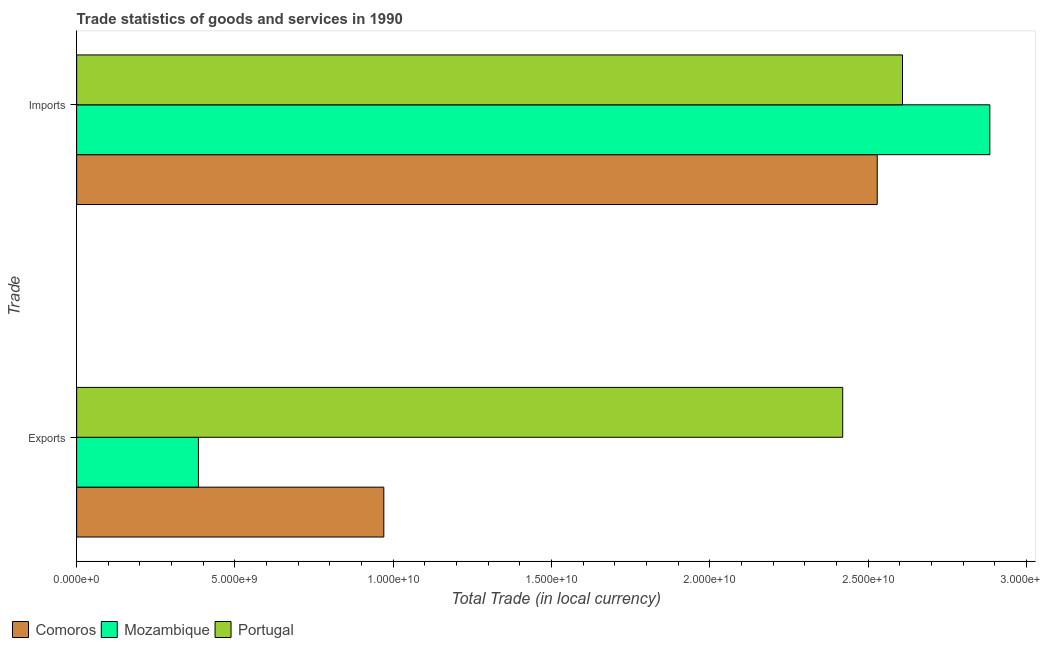How many groups of bars are there?
Offer a very short reply. 2. How many bars are there on the 1st tick from the top?
Give a very brief answer. 3. What is the label of the 1st group of bars from the top?
Make the answer very short. Imports. What is the export of goods and services in Comoros?
Your answer should be compact. 9.70e+09. Across all countries, what is the maximum imports of goods and services?
Make the answer very short. 2.88e+1. Across all countries, what is the minimum export of goods and services?
Provide a short and direct response. 3.85e+09. In which country was the imports of goods and services maximum?
Provide a succinct answer. Mozambique. In which country was the imports of goods and services minimum?
Your answer should be compact. Comoros. What is the total export of goods and services in the graph?
Offer a terse response. 3.77e+1. What is the difference between the imports of goods and services in Mozambique and that in Comoros?
Make the answer very short. 3.56e+09. What is the difference between the imports of goods and services in Portugal and the export of goods and services in Mozambique?
Your answer should be compact. 2.22e+1. What is the average export of goods and services per country?
Your answer should be compact. 1.26e+1. What is the difference between the imports of goods and services and export of goods and services in Comoros?
Offer a terse response. 1.56e+1. In how many countries, is the export of goods and services greater than 5000000000 LCU?
Your answer should be compact. 2. What is the ratio of the export of goods and services in Mozambique to that in Portugal?
Your answer should be very brief. 0.16. Is the imports of goods and services in Comoros less than that in Portugal?
Provide a succinct answer. Yes. In how many countries, is the export of goods and services greater than the average export of goods and services taken over all countries?
Ensure brevity in your answer.  1. What does the 3rd bar from the top in Imports represents?
Offer a terse response. Comoros. What does the 2nd bar from the bottom in Exports represents?
Make the answer very short. Mozambique. What is the difference between two consecutive major ticks on the X-axis?
Your answer should be compact. 5.00e+09. Does the graph contain any zero values?
Provide a succinct answer. No. Does the graph contain grids?
Offer a terse response. No. How many legend labels are there?
Your answer should be very brief. 3. How are the legend labels stacked?
Your answer should be very brief. Horizontal. What is the title of the graph?
Offer a very short reply. Trade statistics of goods and services in 1990. Does "Bermuda" appear as one of the legend labels in the graph?
Ensure brevity in your answer.  No. What is the label or title of the X-axis?
Provide a succinct answer. Total Trade (in local currency). What is the label or title of the Y-axis?
Ensure brevity in your answer.  Trade. What is the Total Trade (in local currency) of Comoros in Exports?
Give a very brief answer. 9.70e+09. What is the Total Trade (in local currency) in Mozambique in Exports?
Offer a very short reply. 3.85e+09. What is the Total Trade (in local currency) in Portugal in Exports?
Your answer should be very brief. 2.42e+1. What is the Total Trade (in local currency) of Comoros in Imports?
Your answer should be very brief. 2.53e+1. What is the Total Trade (in local currency) in Mozambique in Imports?
Your answer should be very brief. 2.88e+1. What is the Total Trade (in local currency) in Portugal in Imports?
Make the answer very short. 2.61e+1. Across all Trade, what is the maximum Total Trade (in local currency) in Comoros?
Give a very brief answer. 2.53e+1. Across all Trade, what is the maximum Total Trade (in local currency) in Mozambique?
Your response must be concise. 2.88e+1. Across all Trade, what is the maximum Total Trade (in local currency) in Portugal?
Keep it short and to the point. 2.61e+1. Across all Trade, what is the minimum Total Trade (in local currency) in Comoros?
Provide a succinct answer. 9.70e+09. Across all Trade, what is the minimum Total Trade (in local currency) of Mozambique?
Give a very brief answer. 3.85e+09. Across all Trade, what is the minimum Total Trade (in local currency) in Portugal?
Ensure brevity in your answer.  2.42e+1. What is the total Total Trade (in local currency) of Comoros in the graph?
Provide a succinct answer. 3.50e+1. What is the total Total Trade (in local currency) in Mozambique in the graph?
Keep it short and to the point. 3.27e+1. What is the total Total Trade (in local currency) in Portugal in the graph?
Make the answer very short. 5.03e+1. What is the difference between the Total Trade (in local currency) in Comoros in Exports and that in Imports?
Provide a succinct answer. -1.56e+1. What is the difference between the Total Trade (in local currency) in Mozambique in Exports and that in Imports?
Your answer should be very brief. -2.50e+1. What is the difference between the Total Trade (in local currency) in Portugal in Exports and that in Imports?
Ensure brevity in your answer.  -1.89e+09. What is the difference between the Total Trade (in local currency) of Comoros in Exports and the Total Trade (in local currency) of Mozambique in Imports?
Your response must be concise. -1.91e+1. What is the difference between the Total Trade (in local currency) of Comoros in Exports and the Total Trade (in local currency) of Portugal in Imports?
Offer a terse response. -1.64e+1. What is the difference between the Total Trade (in local currency) in Mozambique in Exports and the Total Trade (in local currency) in Portugal in Imports?
Keep it short and to the point. -2.22e+1. What is the average Total Trade (in local currency) of Comoros per Trade?
Keep it short and to the point. 1.75e+1. What is the average Total Trade (in local currency) in Mozambique per Trade?
Give a very brief answer. 1.63e+1. What is the average Total Trade (in local currency) of Portugal per Trade?
Make the answer very short. 2.51e+1. What is the difference between the Total Trade (in local currency) in Comoros and Total Trade (in local currency) in Mozambique in Exports?
Your answer should be very brief. 5.86e+09. What is the difference between the Total Trade (in local currency) in Comoros and Total Trade (in local currency) in Portugal in Exports?
Your response must be concise. -1.45e+1. What is the difference between the Total Trade (in local currency) in Mozambique and Total Trade (in local currency) in Portugal in Exports?
Your response must be concise. -2.04e+1. What is the difference between the Total Trade (in local currency) in Comoros and Total Trade (in local currency) in Mozambique in Imports?
Provide a short and direct response. -3.56e+09. What is the difference between the Total Trade (in local currency) in Comoros and Total Trade (in local currency) in Portugal in Imports?
Provide a short and direct response. -7.98e+08. What is the difference between the Total Trade (in local currency) of Mozambique and Total Trade (in local currency) of Portugal in Imports?
Keep it short and to the point. 2.76e+09. What is the ratio of the Total Trade (in local currency) in Comoros in Exports to that in Imports?
Keep it short and to the point. 0.38. What is the ratio of the Total Trade (in local currency) of Mozambique in Exports to that in Imports?
Ensure brevity in your answer.  0.13. What is the ratio of the Total Trade (in local currency) in Portugal in Exports to that in Imports?
Offer a very short reply. 0.93. What is the difference between the highest and the second highest Total Trade (in local currency) in Comoros?
Your answer should be compact. 1.56e+1. What is the difference between the highest and the second highest Total Trade (in local currency) in Mozambique?
Offer a very short reply. 2.50e+1. What is the difference between the highest and the second highest Total Trade (in local currency) in Portugal?
Your answer should be very brief. 1.89e+09. What is the difference between the highest and the lowest Total Trade (in local currency) of Comoros?
Offer a terse response. 1.56e+1. What is the difference between the highest and the lowest Total Trade (in local currency) in Mozambique?
Offer a very short reply. 2.50e+1. What is the difference between the highest and the lowest Total Trade (in local currency) of Portugal?
Keep it short and to the point. 1.89e+09. 